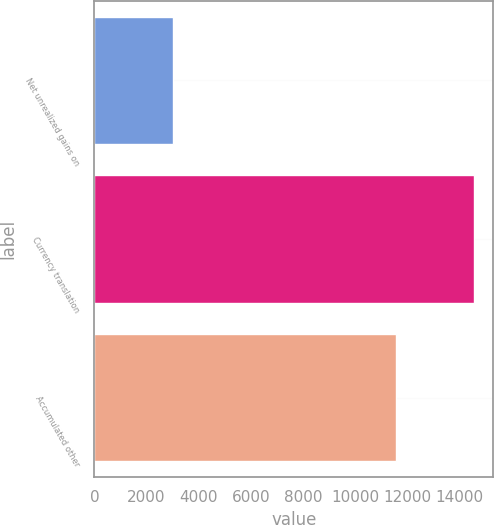Convert chart. <chart><loc_0><loc_0><loc_500><loc_500><bar_chart><fcel>Net unrealized gains on<fcel>Currency translation<fcel>Accumulated other<nl><fcel>2999<fcel>14567<fcel>11568<nl></chart> 